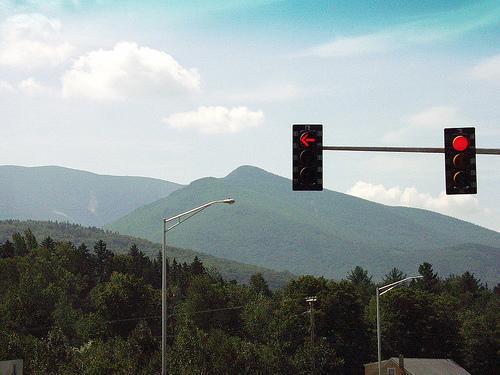How many street lights are shown?
Give a very brief answer. 2. How many traffic lights are here?
Give a very brief answer. 2. 